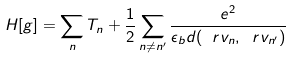Convert formula to latex. <formula><loc_0><loc_0><loc_500><loc_500>H [ { g } ] = \sum _ { n } T _ { n } + \frac { 1 } { 2 } \sum _ { n \neq n ^ { \prime } } \frac { e ^ { 2 } } { \epsilon _ { b } d ( \ r v _ { n } , \ r v _ { n ^ { \prime } } ) }</formula> 